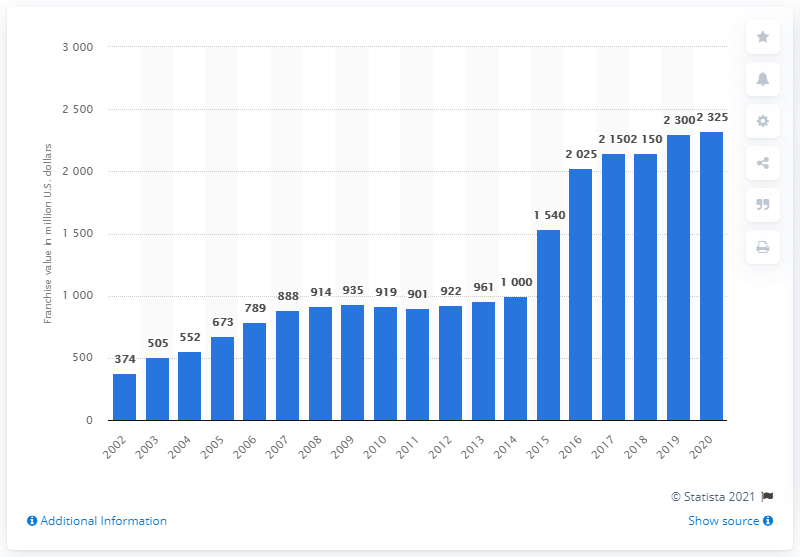Give some essential details in this illustration. The value of the Arizona Cardinals in dollars in 2020 was 2,325. 